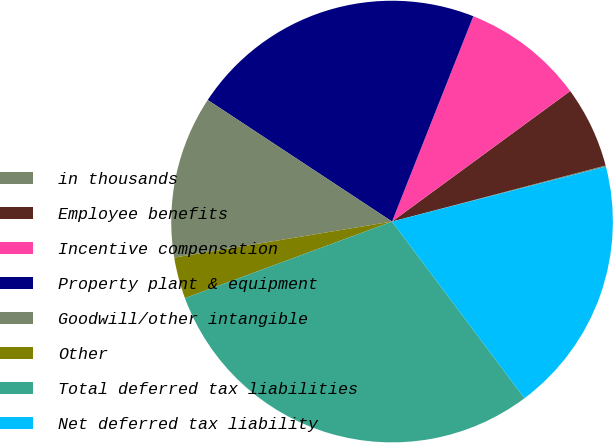Convert chart to OTSL. <chart><loc_0><loc_0><loc_500><loc_500><pie_chart><fcel>in thousands<fcel>Employee benefits<fcel>Incentive compensation<fcel>Property plant & equipment<fcel>Goodwill/other intangible<fcel>Other<fcel>Total deferred tax liabilities<fcel>Net deferred tax liability<nl><fcel>0.08%<fcel>5.98%<fcel>8.94%<fcel>21.72%<fcel>11.89%<fcel>3.03%<fcel>29.6%<fcel>18.77%<nl></chart> 